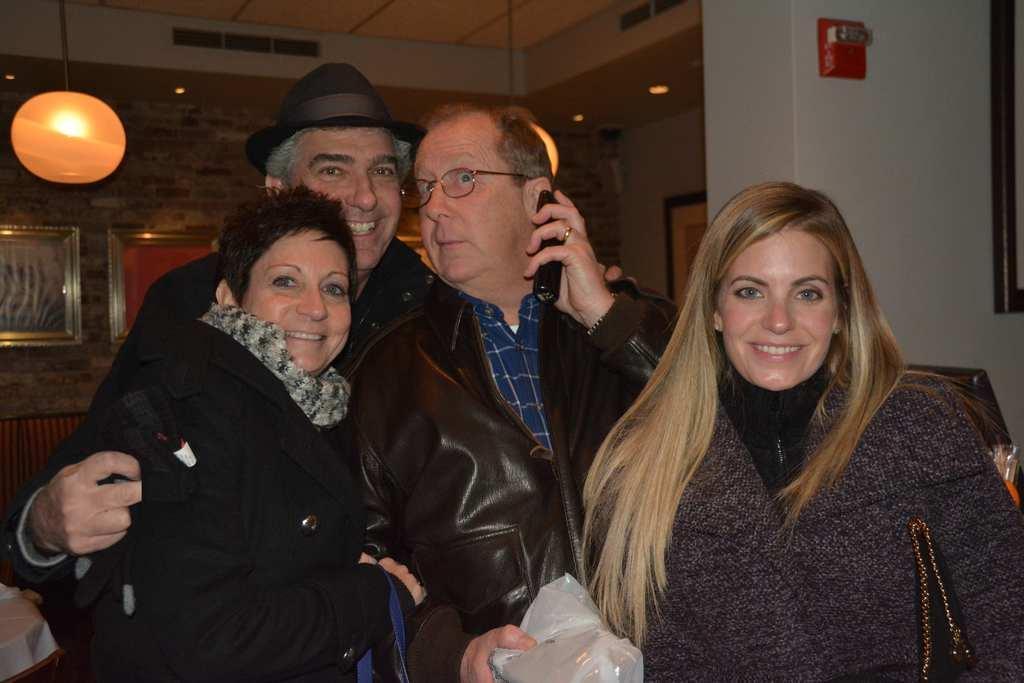Describe this image in one or two sentences. In this image in the front group of persons standing and smiling. In the background there is light hanging and on the wall there are frames and there is a sofa. On the left side there is a table which is covered with a white colour cloth. 